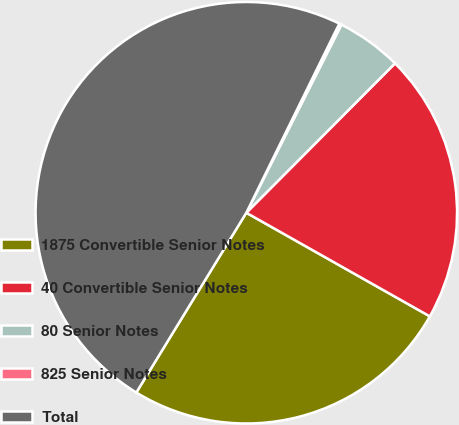<chart> <loc_0><loc_0><loc_500><loc_500><pie_chart><fcel>1875 Convertible Senior Notes<fcel>40 Convertible Senior Notes<fcel>80 Senior Notes<fcel>825 Senior Notes<fcel>Total<nl><fcel>25.56%<fcel>20.72%<fcel>5.01%<fcel>0.18%<fcel>48.54%<nl></chart> 